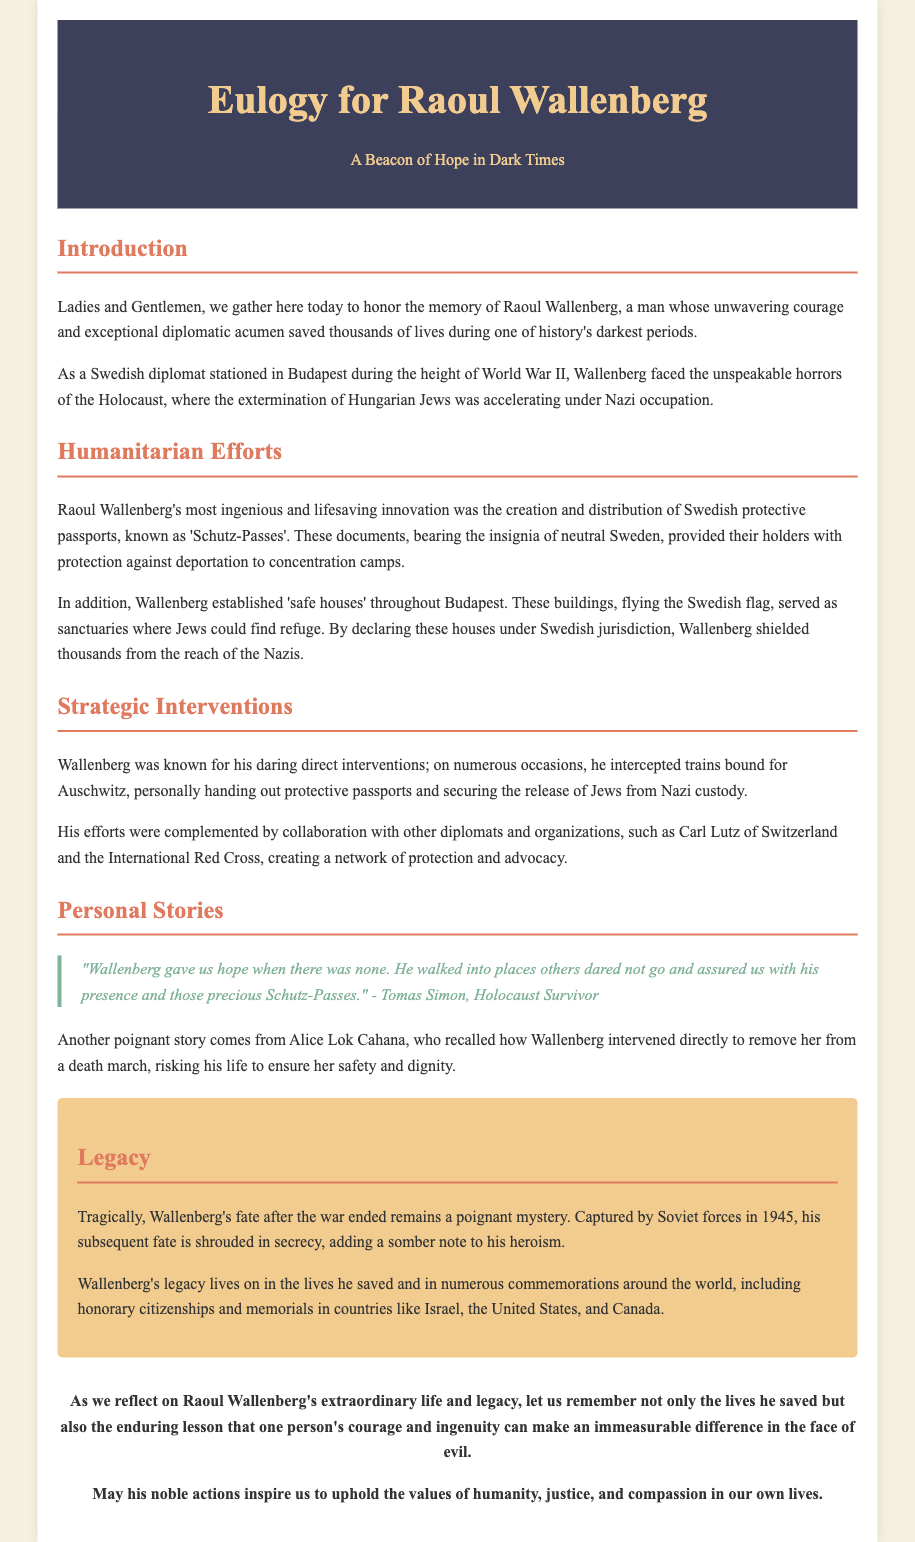What was Raoul Wallenberg's role during World War II? Raoul Wallenberg was a Swedish diplomat stationed in Budapest during the height of World War II, where he saved thousands of lives.
Answer: Swedish diplomat What innovative document did Wallenberg create? Wallenberg created and distributed Swedish protective passports, known as 'Schutz-Passes', to protect Hungarian Jews.
Answer: Schutz-Passes What did Wallenberg establish in Budapest to shelter Jews? Wallenberg established 'safe houses' throughout Budapest that served as sanctuaries for Jews.
Answer: Safe houses Who collaborated with Wallenberg in his efforts? Wallenberg collaborated with other diplomats and organizations, including Carl Lutz of Switzerland and the International Red Cross.
Answer: Carl Lutz What happened to Wallenberg after the war? Wallenberg was captured by Soviet forces in 1945, and his subsequent fate remains unknown.
Answer: Captured by Soviet forces How did survivors describe Wallenberg's presence? Survivors described Wallenberg as a source of hope who walked into dangerous places with protective passports.
Answer: A source of hope What lasting recognition did Wallenberg receive? Wallenberg's legacy is commemorated in numerous countries, including honorary citizenships and memorials.
Answer: Honorary citizenships What motto does the eulogy suggest we should uphold? The conclusion suggests upholding the values of humanity, justice, and compassion in our lives.
Answer: Humanity, justice, and compassion 